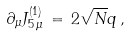Convert formula to latex. <formula><loc_0><loc_0><loc_500><loc_500>\partial _ { \mu } J ^ { ( 1 ) } _ { 5 \, \mu } \, = \, 2 \sqrt { N } q \, ,</formula> 